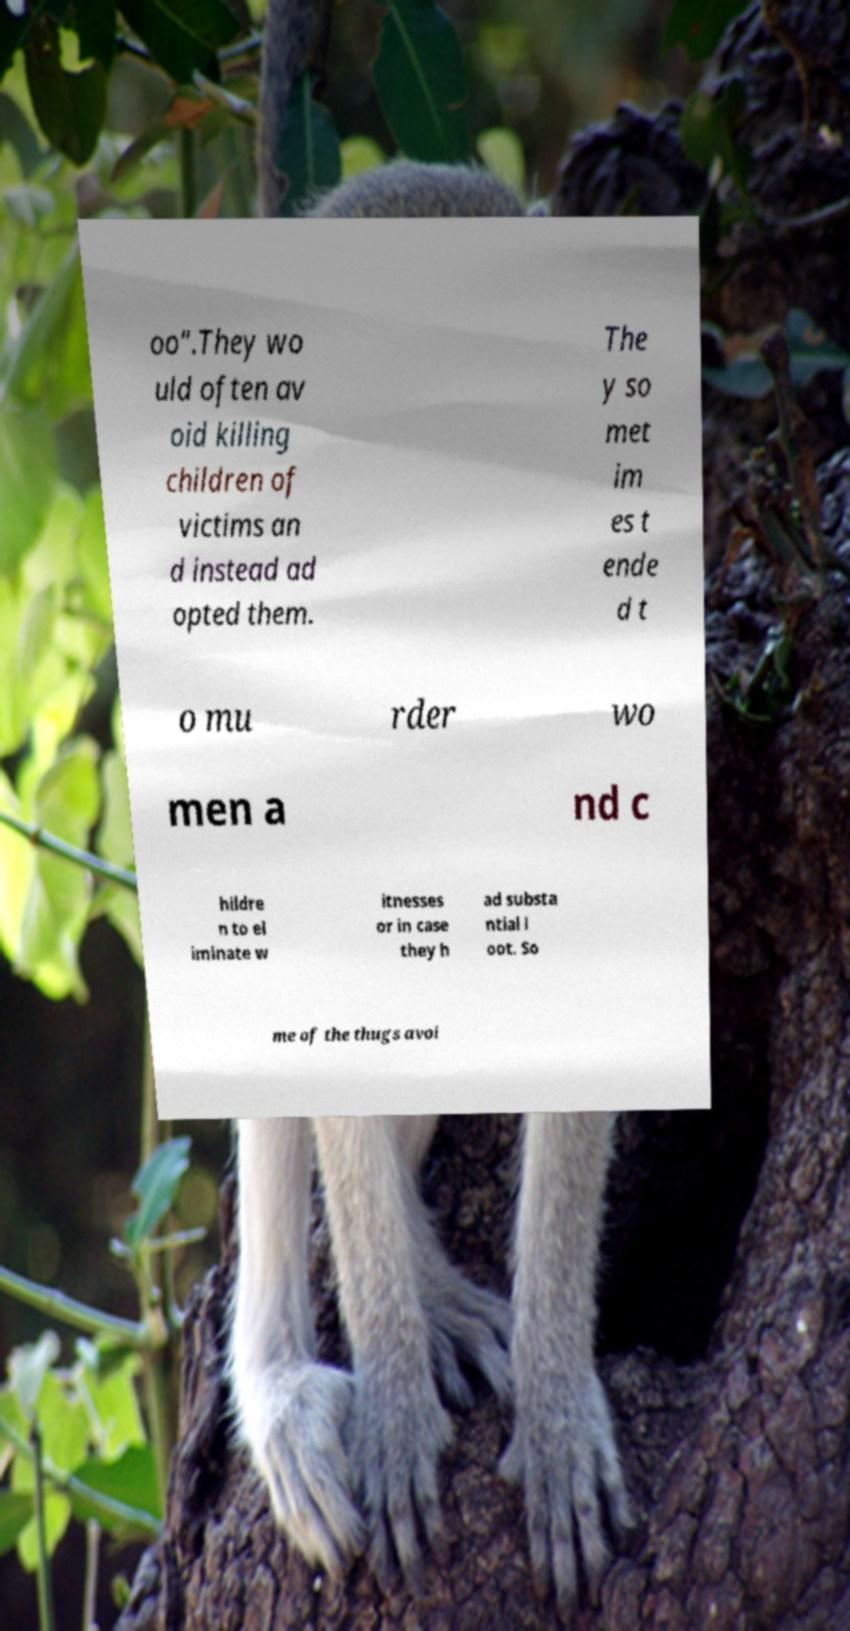For documentation purposes, I need the text within this image transcribed. Could you provide that? oo".They wo uld often av oid killing children of victims an d instead ad opted them. The y so met im es t ende d t o mu rder wo men a nd c hildre n to el iminate w itnesses or in case they h ad substa ntial l oot. So me of the thugs avoi 